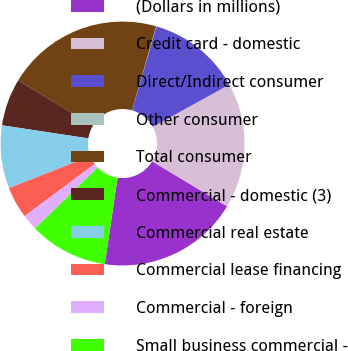Convert chart. <chart><loc_0><loc_0><loc_500><loc_500><pie_chart><fcel>(Dollars in millions)<fcel>Credit card - domestic<fcel>Direct/Indirect consumer<fcel>Other consumer<fcel>Total consumer<fcel>Commercial - domestic (3)<fcel>Commercial real estate<fcel>Commercial lease financing<fcel>Commercial - foreign<fcel>Small business commercial -<nl><fcel>18.71%<fcel>16.63%<fcel>12.49%<fcel>0.05%<fcel>20.78%<fcel>6.27%<fcel>8.34%<fcel>4.19%<fcel>2.12%<fcel>10.41%<nl></chart> 